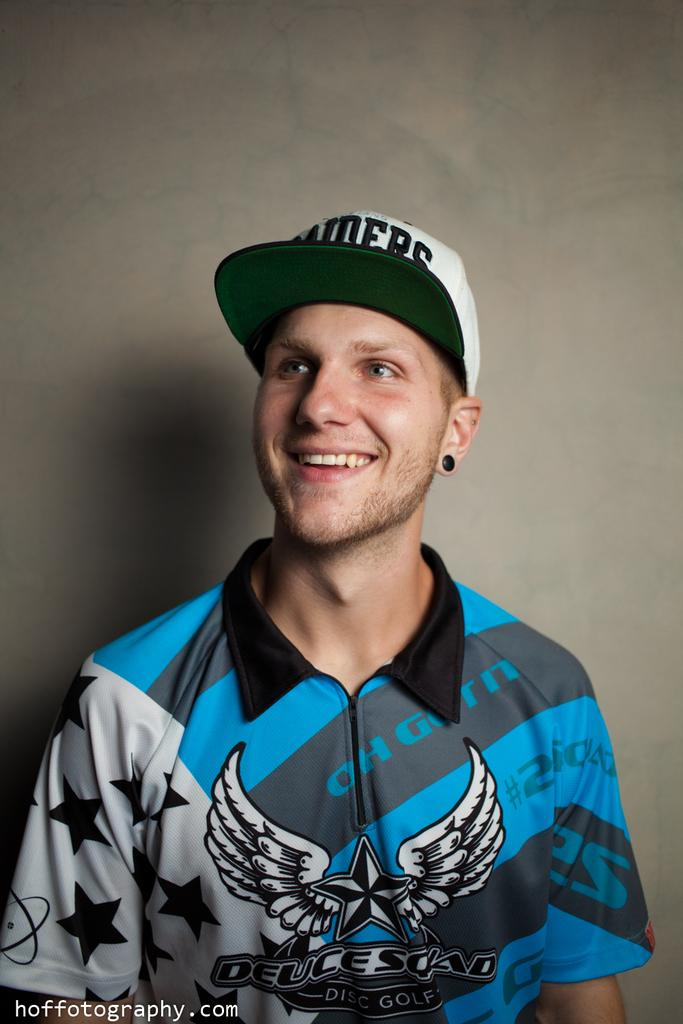<image>
Provide a brief description of the given image. A man wears a blue, white and black shirt that says, "Deuce." 